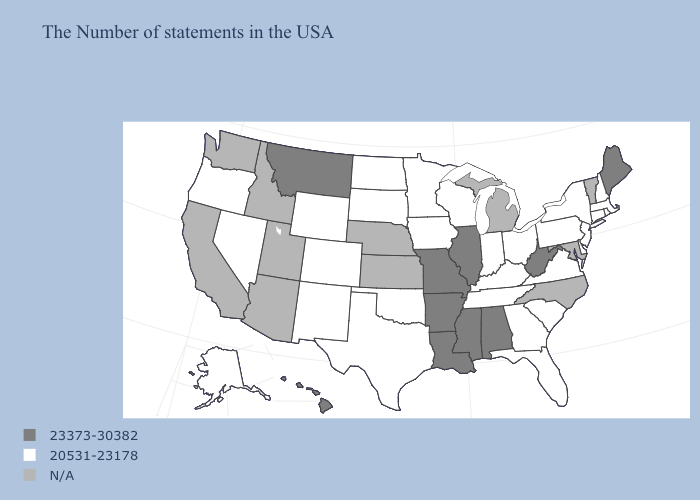What is the value of Washington?
Short answer required. N/A. Does Oklahoma have the lowest value in the USA?
Keep it brief. Yes. Does Maine have the lowest value in the USA?
Write a very short answer. No. What is the highest value in states that border New Jersey?
Keep it brief. 20531-23178. Which states have the highest value in the USA?
Short answer required. Maine, West Virginia, Alabama, Illinois, Mississippi, Louisiana, Missouri, Arkansas, Montana, Hawaii. How many symbols are there in the legend?
Keep it brief. 3. Does Virginia have the highest value in the South?
Keep it brief. No. What is the lowest value in the USA?
Concise answer only. 20531-23178. How many symbols are there in the legend?
Concise answer only. 3. What is the value of New Jersey?
Be succinct. 20531-23178. What is the highest value in the USA?
Keep it brief. 23373-30382. Does New Jersey have the lowest value in the Northeast?
Be succinct. Yes. What is the value of Hawaii?
Short answer required. 23373-30382. What is the value of Arkansas?
Keep it brief. 23373-30382. Is the legend a continuous bar?
Write a very short answer. No. 